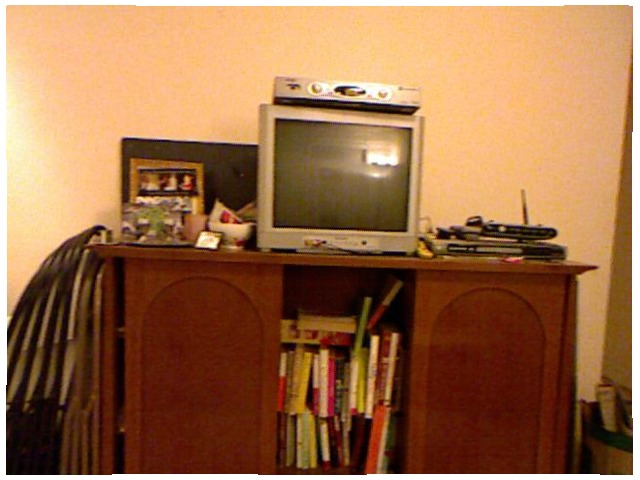<image>
Is there a television in front of the cd player? No. The television is not in front of the cd player. The spatial positioning shows a different relationship between these objects. Is there a tv above the books? Yes. The tv is positioned above the books in the vertical space, higher up in the scene. Where is the vcd in relation to the tv? Is it on the tv? Yes. Looking at the image, I can see the vcd is positioned on top of the tv, with the tv providing support. Is the tv on the wall? Yes. Looking at the image, I can see the tv is positioned on top of the wall, with the wall providing support. Is the tv on the books? No. The tv is not positioned on the books. They may be near each other, but the tv is not supported by or resting on top of the books. Is the televison on the stereo? No. The televison is not positioned on the stereo. They may be near each other, but the televison is not supported by or resting on top of the stereo. Where is the tv in relation to the cable box? Is it to the right of the cable box? No. The tv is not to the right of the cable box. The horizontal positioning shows a different relationship. 